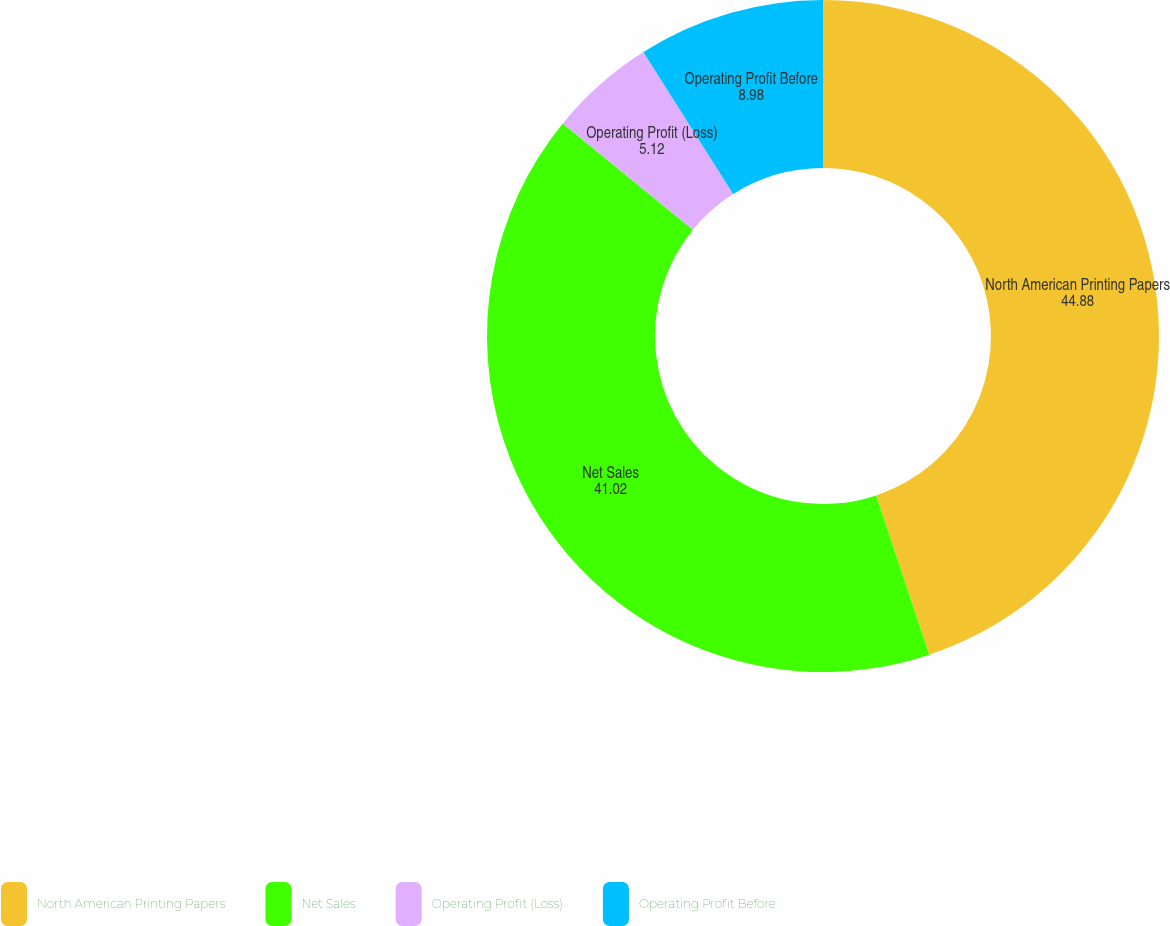<chart> <loc_0><loc_0><loc_500><loc_500><pie_chart><fcel>North American Printing Papers<fcel>Net Sales<fcel>Operating Profit (Loss)<fcel>Operating Profit Before<nl><fcel>44.88%<fcel>41.02%<fcel>5.12%<fcel>8.98%<nl></chart> 